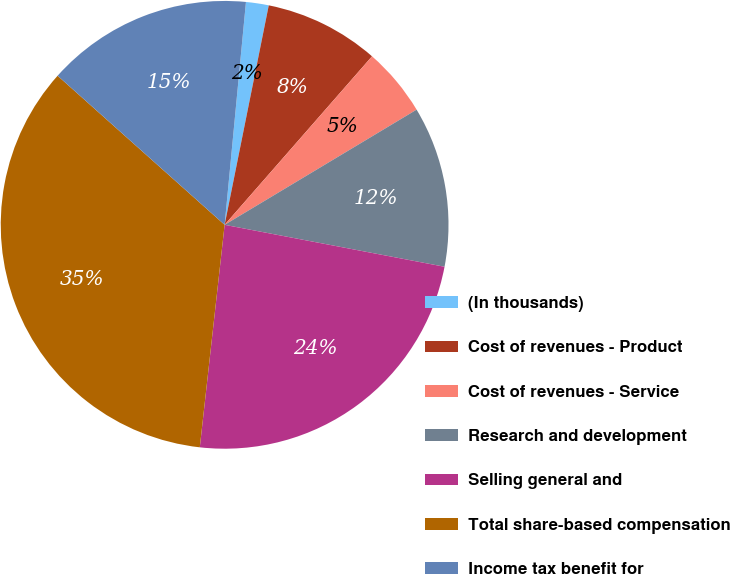Convert chart. <chart><loc_0><loc_0><loc_500><loc_500><pie_chart><fcel>(In thousands)<fcel>Cost of revenues - Product<fcel>Cost of revenues - Service<fcel>Research and development<fcel>Selling general and<fcel>Total share-based compensation<fcel>Income tax benefit for<nl><fcel>1.64%<fcel>8.28%<fcel>4.96%<fcel>11.6%<fcel>23.77%<fcel>34.83%<fcel>14.92%<nl></chart> 